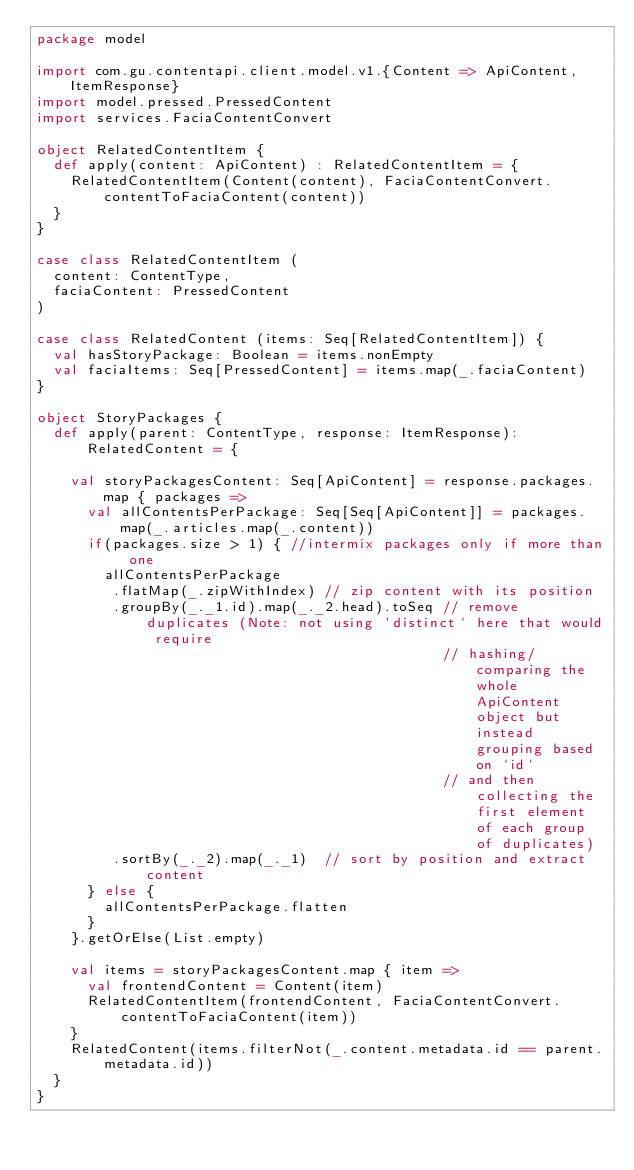<code> <loc_0><loc_0><loc_500><loc_500><_Scala_>package model

import com.gu.contentapi.client.model.v1.{Content => ApiContent, ItemResponse}
import model.pressed.PressedContent
import services.FaciaContentConvert

object RelatedContentItem {
  def apply(content: ApiContent) : RelatedContentItem = {
    RelatedContentItem(Content(content), FaciaContentConvert.contentToFaciaContent(content))
  }
}

case class RelatedContentItem (
  content: ContentType,
  faciaContent: PressedContent
)

case class RelatedContent (items: Seq[RelatedContentItem]) {
  val hasStoryPackage: Boolean = items.nonEmpty
  val faciaItems: Seq[PressedContent] = items.map(_.faciaContent)
}

object StoryPackages {
  def apply(parent: ContentType, response: ItemResponse): RelatedContent = {

    val storyPackagesContent: Seq[ApiContent] = response.packages.map { packages =>
      val allContentsPerPackage: Seq[Seq[ApiContent]] = packages.map(_.articles.map(_.content))
      if(packages.size > 1) { //intermix packages only if more than one
        allContentsPerPackage
         .flatMap(_.zipWithIndex) // zip content with its position
         .groupBy(_._1.id).map(_._2.head).toSeq // remove duplicates (Note: not using `distinct` here that would require
                                                // hashing/comparing the whole ApiContent object but instead grouping based on `id`
                                                // and then collecting the first element of each group of duplicates)
         .sortBy(_._2).map(_._1)  // sort by position and extract content
      } else {
        allContentsPerPackage.flatten
      }
    }.getOrElse(List.empty)

    val items = storyPackagesContent.map { item =>
      val frontendContent = Content(item)
      RelatedContentItem(frontendContent, FaciaContentConvert.contentToFaciaContent(item))
    }
    RelatedContent(items.filterNot(_.content.metadata.id == parent.metadata.id))
  }
}
</code> 